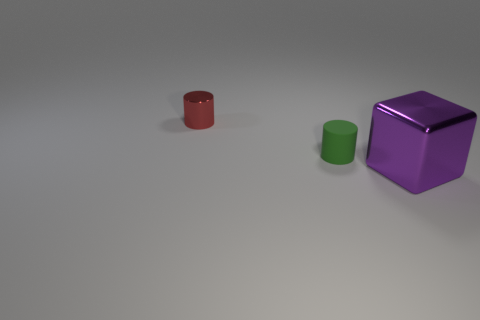Add 2 purple blocks. How many objects exist? 5 Subtract all cubes. How many objects are left? 2 Subtract all small green matte cylinders. Subtract all red metallic objects. How many objects are left? 1 Add 2 red metallic cylinders. How many red metallic cylinders are left? 3 Add 1 red cylinders. How many red cylinders exist? 2 Subtract 0 green spheres. How many objects are left? 3 